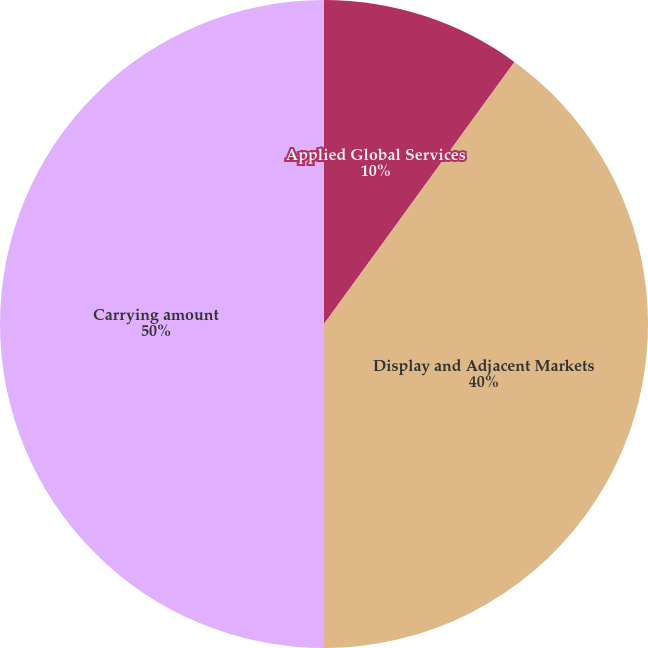<chart> <loc_0><loc_0><loc_500><loc_500><pie_chart><fcel>Applied Global Services<fcel>Display and Adjacent Markets<fcel>Carrying amount<nl><fcel>10.0%<fcel>40.0%<fcel>50.0%<nl></chart> 